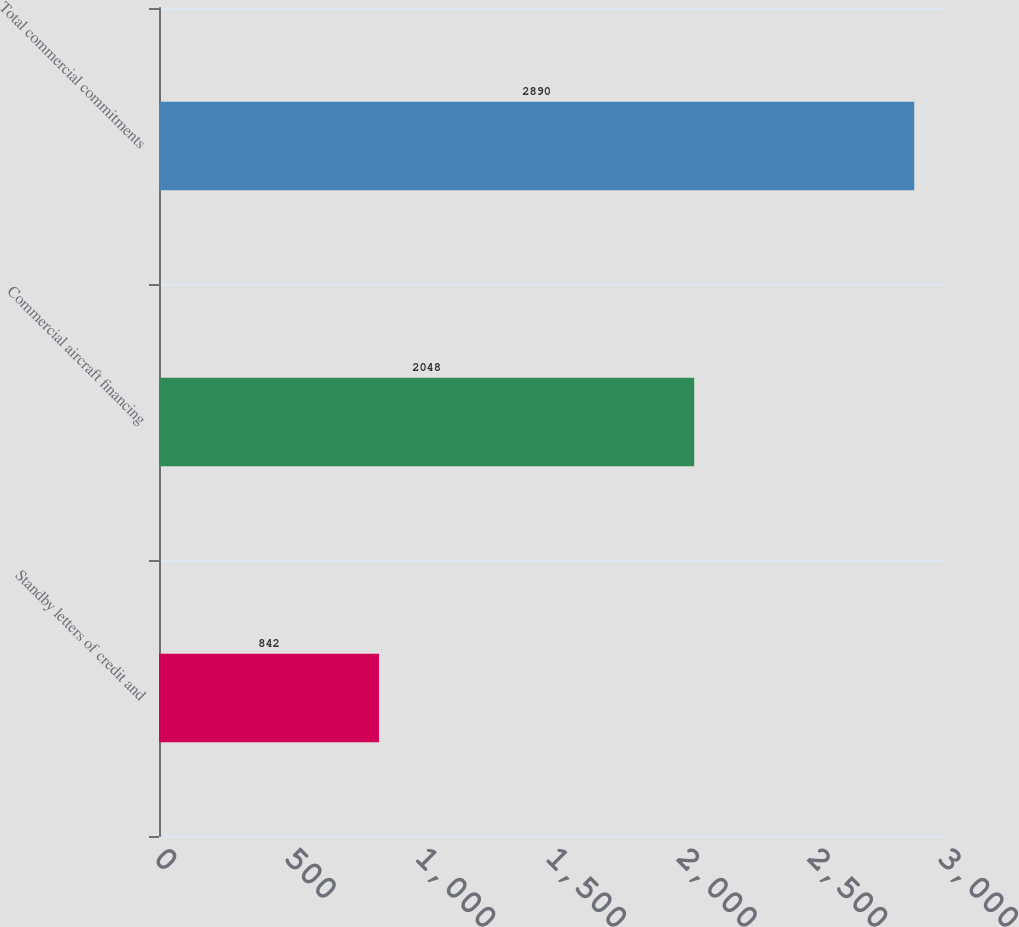<chart> <loc_0><loc_0><loc_500><loc_500><bar_chart><fcel>Standby letters of credit and<fcel>Commercial aircraft financing<fcel>Total commercial commitments<nl><fcel>842<fcel>2048<fcel>2890<nl></chart> 